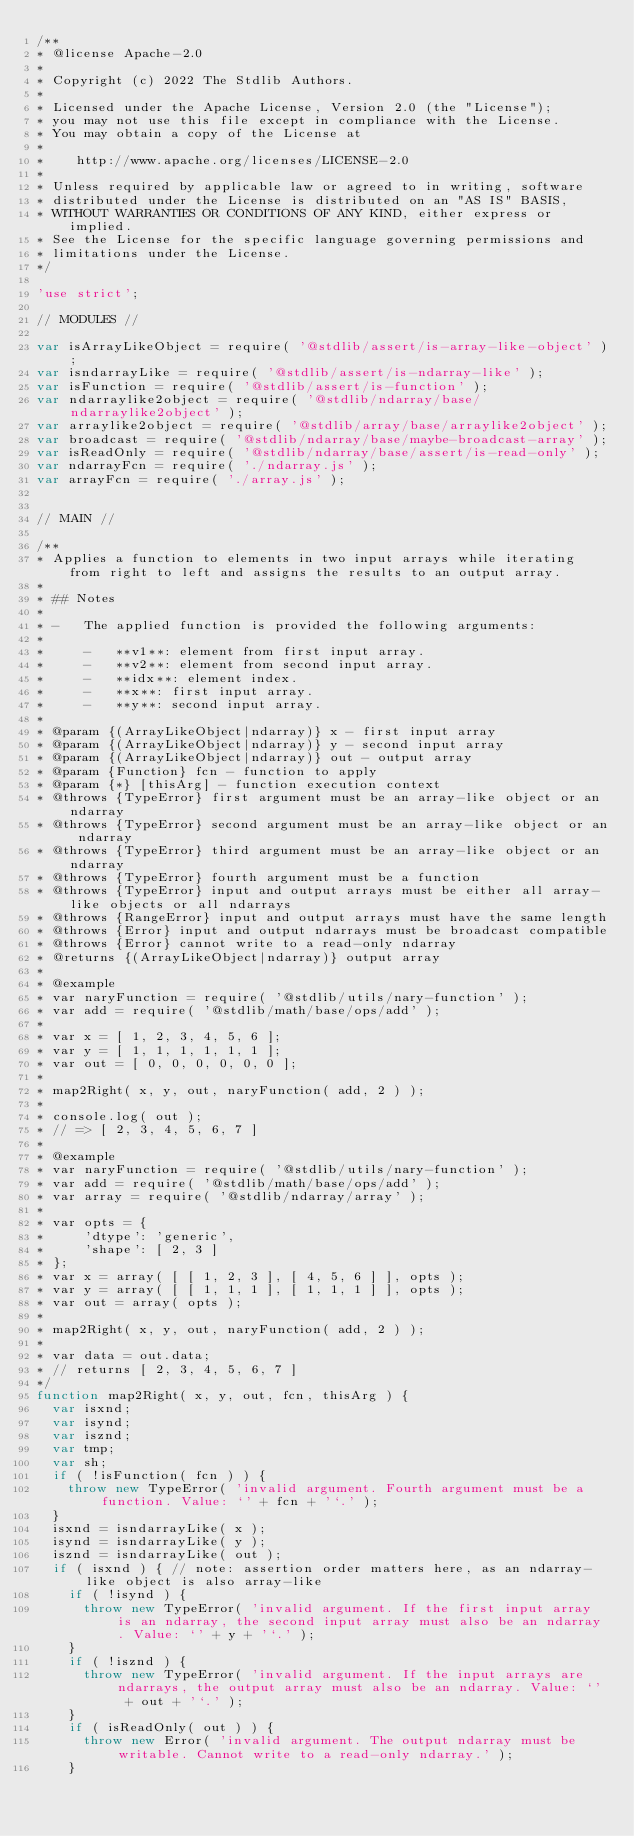<code> <loc_0><loc_0><loc_500><loc_500><_JavaScript_>/**
* @license Apache-2.0
*
* Copyright (c) 2022 The Stdlib Authors.
*
* Licensed under the Apache License, Version 2.0 (the "License");
* you may not use this file except in compliance with the License.
* You may obtain a copy of the License at
*
*    http://www.apache.org/licenses/LICENSE-2.0
*
* Unless required by applicable law or agreed to in writing, software
* distributed under the License is distributed on an "AS IS" BASIS,
* WITHOUT WARRANTIES OR CONDITIONS OF ANY KIND, either express or implied.
* See the License for the specific language governing permissions and
* limitations under the License.
*/

'use strict';

// MODULES //

var isArrayLikeObject = require( '@stdlib/assert/is-array-like-object' );
var isndarrayLike = require( '@stdlib/assert/is-ndarray-like' );
var isFunction = require( '@stdlib/assert/is-function' );
var ndarraylike2object = require( '@stdlib/ndarray/base/ndarraylike2object' );
var arraylike2object = require( '@stdlib/array/base/arraylike2object' );
var broadcast = require( '@stdlib/ndarray/base/maybe-broadcast-array' );
var isReadOnly = require( '@stdlib/ndarray/base/assert/is-read-only' );
var ndarrayFcn = require( './ndarray.js' );
var arrayFcn = require( './array.js' );


// MAIN //

/**
* Applies a function to elements in two input arrays while iterating from right to left and assigns the results to an output array.
*
* ## Notes
*
* -   The applied function is provided the following arguments:
*
*     -   **v1**: element from first input array.
*     -   **v2**: element from second input array.
*     -   **idx**: element index.
*     -   **x**: first input array.
*     -   **y**: second input array.
*
* @param {(ArrayLikeObject|ndarray)} x - first input array
* @param {(ArrayLikeObject|ndarray)} y - second input array
* @param {(ArrayLikeObject|ndarray)} out - output array
* @param {Function} fcn - function to apply
* @param {*} [thisArg] - function execution context
* @throws {TypeError} first argument must be an array-like object or an ndarray
* @throws {TypeError} second argument must be an array-like object or an ndarray
* @throws {TypeError} third argument must be an array-like object or an ndarray
* @throws {TypeError} fourth argument must be a function
* @throws {TypeError} input and output arrays must be either all array-like objects or all ndarrays
* @throws {RangeError} input and output arrays must have the same length
* @throws {Error} input and output ndarrays must be broadcast compatible
* @throws {Error} cannot write to a read-only ndarray
* @returns {(ArrayLikeObject|ndarray)} output array
*
* @example
* var naryFunction = require( '@stdlib/utils/nary-function' );
* var add = require( '@stdlib/math/base/ops/add' );
*
* var x = [ 1, 2, 3, 4, 5, 6 ];
* var y = [ 1, 1, 1, 1, 1, 1 ];
* var out = [ 0, 0, 0, 0, 0, 0 ];
*
* map2Right( x, y, out, naryFunction( add, 2 ) );
*
* console.log( out );
* // => [ 2, 3, 4, 5, 6, 7 ]
*
* @example
* var naryFunction = require( '@stdlib/utils/nary-function' );
* var add = require( '@stdlib/math/base/ops/add' );
* var array = require( '@stdlib/ndarray/array' );
*
* var opts = {
*     'dtype': 'generic',
*     'shape': [ 2, 3 ]
* };
* var x = array( [ [ 1, 2, 3 ], [ 4, 5, 6 ] ], opts );
* var y = array( [ [ 1, 1, 1 ], [ 1, 1, 1 ] ], opts );
* var out = array( opts );
*
* map2Right( x, y, out, naryFunction( add, 2 ) );
*
* var data = out.data;
* // returns [ 2, 3, 4, 5, 6, 7 ]
*/
function map2Right( x, y, out, fcn, thisArg ) {
	var isxnd;
	var isynd;
	var isznd;
	var tmp;
	var sh;
	if ( !isFunction( fcn ) ) {
		throw new TypeError( 'invalid argument. Fourth argument must be a function. Value: `' + fcn + '`.' );
	}
	isxnd = isndarrayLike( x );
	isynd = isndarrayLike( y );
	isznd = isndarrayLike( out );
	if ( isxnd ) { // note: assertion order matters here, as an ndarray-like object is also array-like
		if ( !isynd ) {
			throw new TypeError( 'invalid argument. If the first input array is an ndarray, the second input array must also be an ndarray. Value: `' + y + '`.' );
		}
		if ( !isznd ) {
			throw new TypeError( 'invalid argument. If the input arrays are ndarrays, the output array must also be an ndarray. Value: `' + out + '`.' );
		}
		if ( isReadOnly( out ) ) {
			throw new Error( 'invalid argument. The output ndarray must be writable. Cannot write to a read-only ndarray.' );
		}</code> 